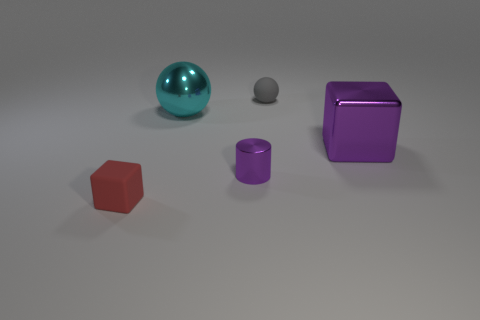There is a small purple object in front of the block that is right of the small red object; what is its material? The small purple object appears to have a matte finish, suggesting it is made from a non-reflective material like plastic. 